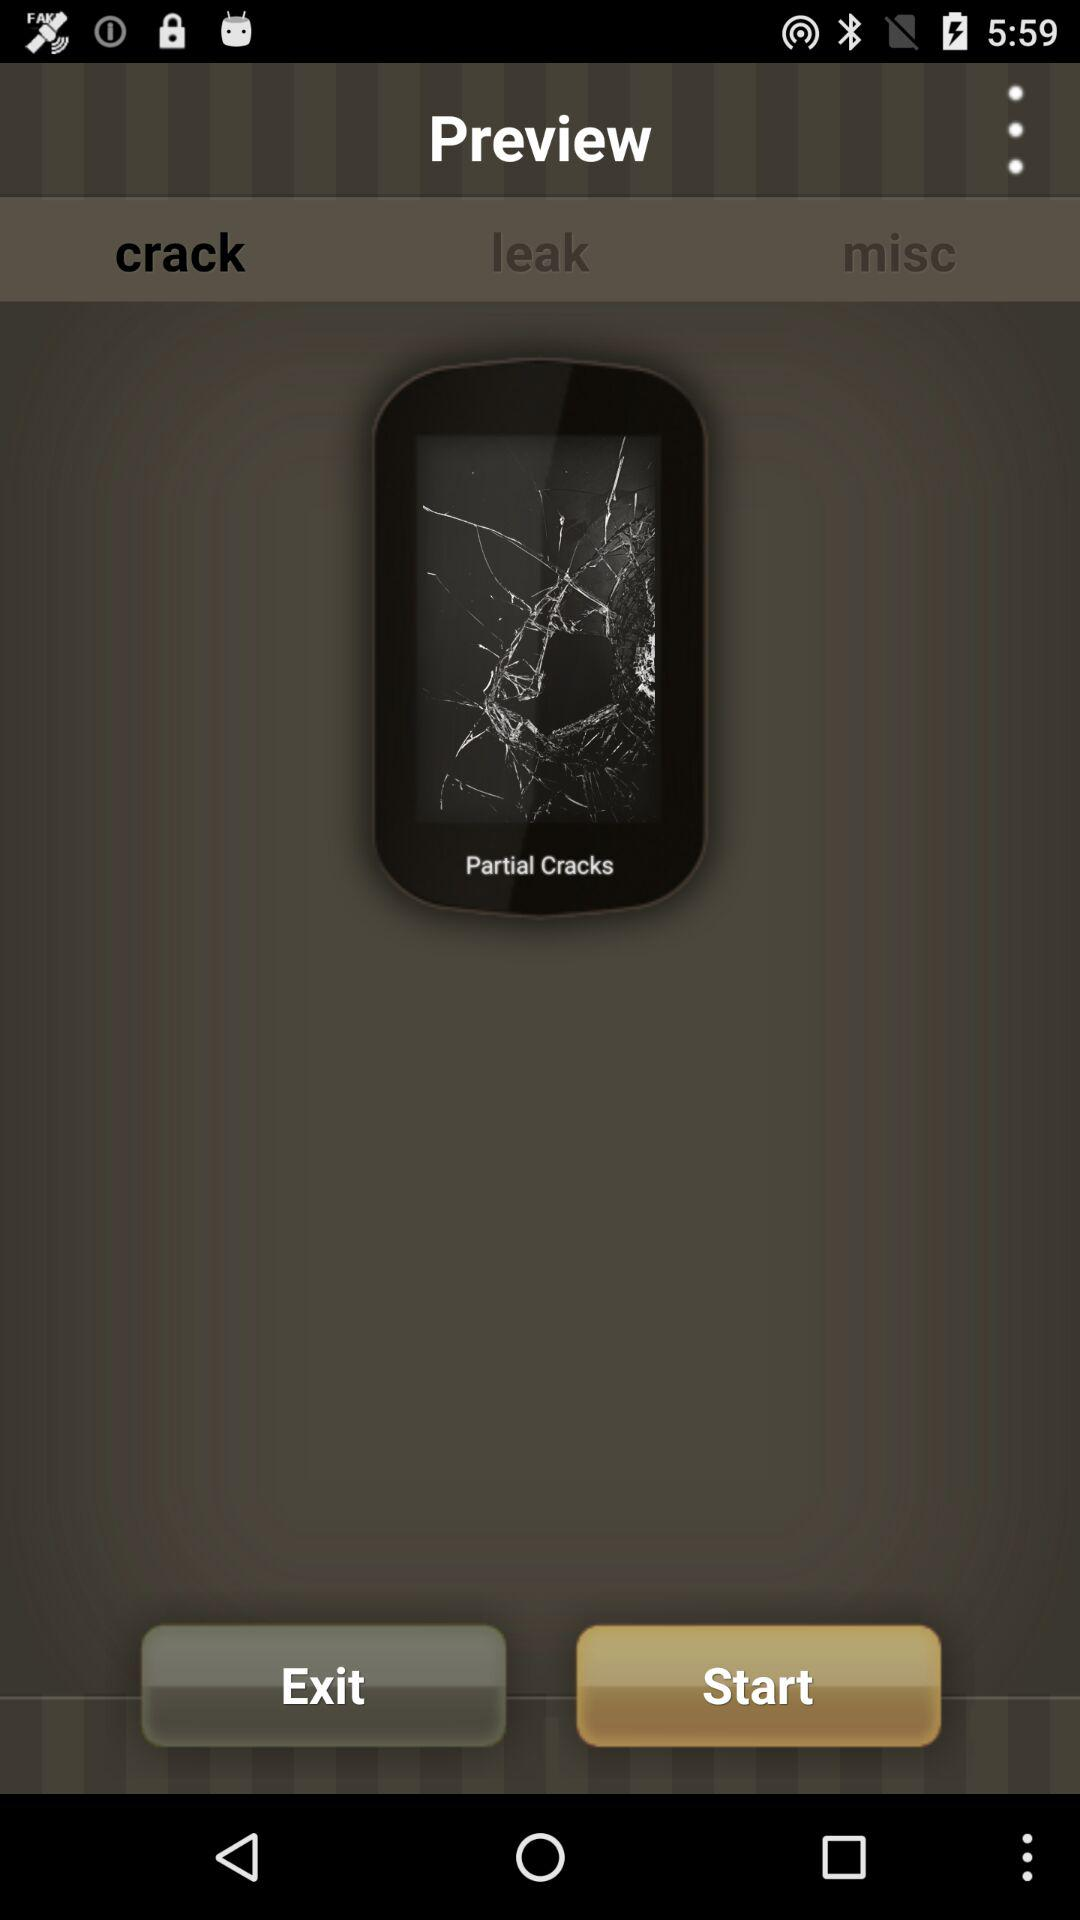What is the name of the application?
When the provided information is insufficient, respond with <no answer>. <no answer> 